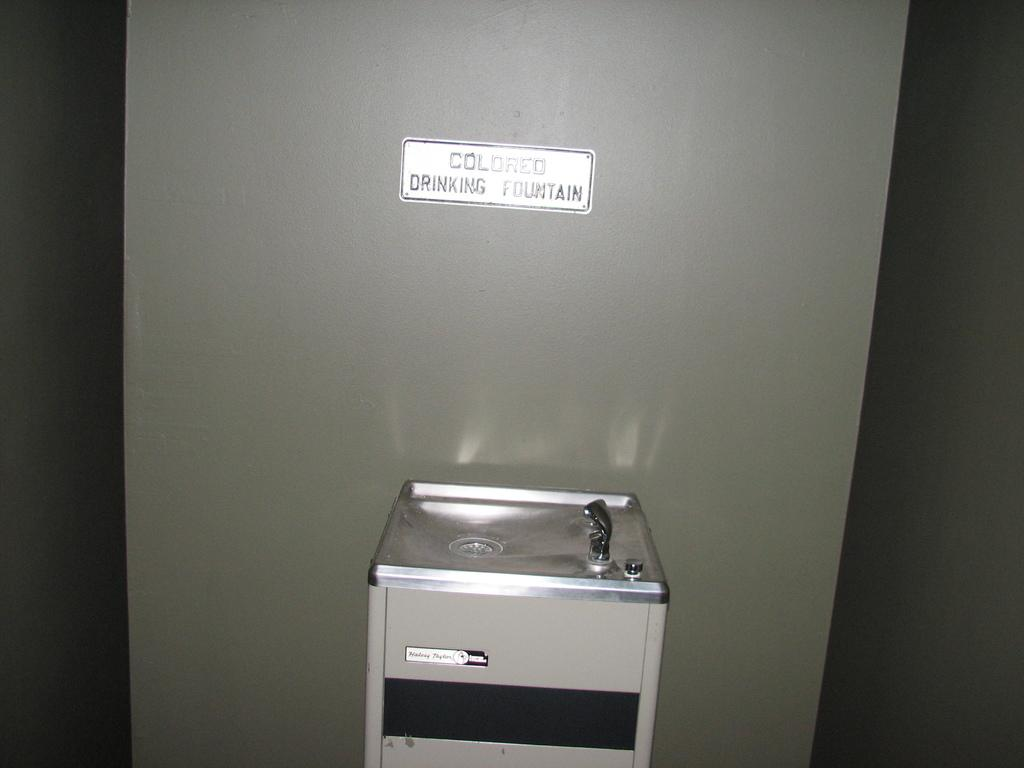<image>
Describe the image concisely. The sign above the drinking fountain says colored drinking fountain 